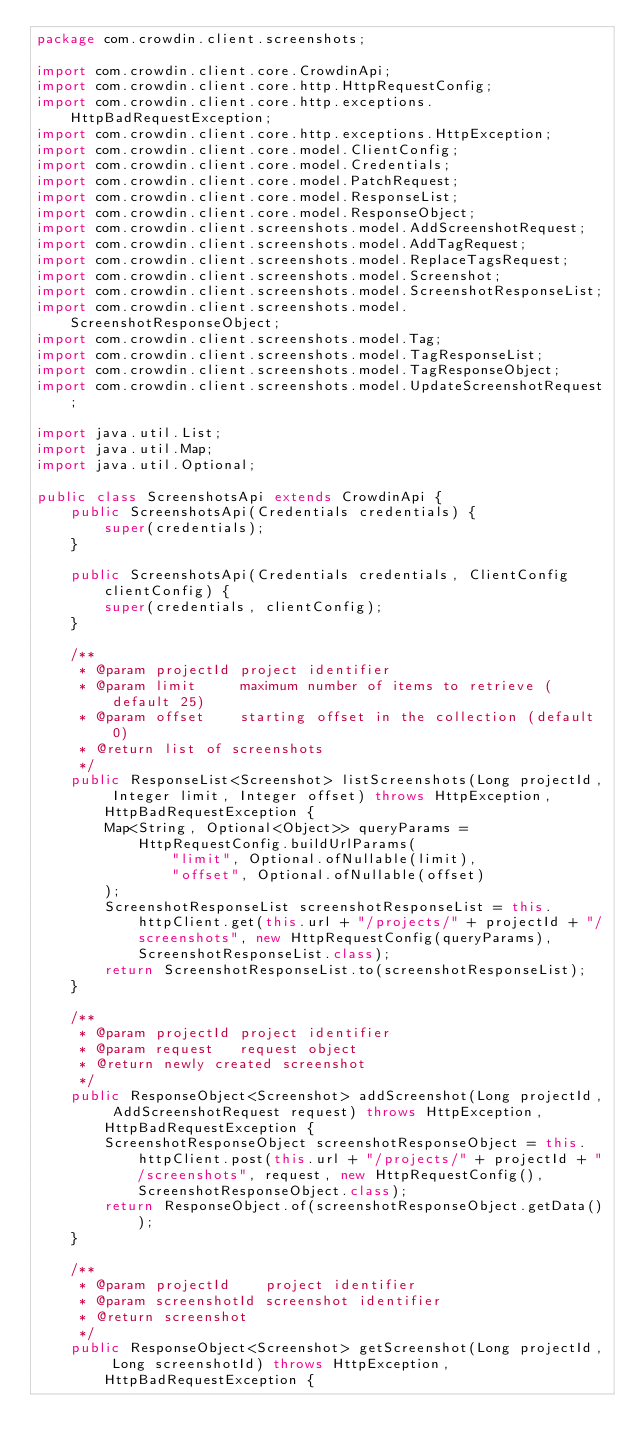Convert code to text. <code><loc_0><loc_0><loc_500><loc_500><_Java_>package com.crowdin.client.screenshots;

import com.crowdin.client.core.CrowdinApi;
import com.crowdin.client.core.http.HttpRequestConfig;
import com.crowdin.client.core.http.exceptions.HttpBadRequestException;
import com.crowdin.client.core.http.exceptions.HttpException;
import com.crowdin.client.core.model.ClientConfig;
import com.crowdin.client.core.model.Credentials;
import com.crowdin.client.core.model.PatchRequest;
import com.crowdin.client.core.model.ResponseList;
import com.crowdin.client.core.model.ResponseObject;
import com.crowdin.client.screenshots.model.AddScreenshotRequest;
import com.crowdin.client.screenshots.model.AddTagRequest;
import com.crowdin.client.screenshots.model.ReplaceTagsRequest;
import com.crowdin.client.screenshots.model.Screenshot;
import com.crowdin.client.screenshots.model.ScreenshotResponseList;
import com.crowdin.client.screenshots.model.ScreenshotResponseObject;
import com.crowdin.client.screenshots.model.Tag;
import com.crowdin.client.screenshots.model.TagResponseList;
import com.crowdin.client.screenshots.model.TagResponseObject;
import com.crowdin.client.screenshots.model.UpdateScreenshotRequest;

import java.util.List;
import java.util.Map;
import java.util.Optional;

public class ScreenshotsApi extends CrowdinApi {
    public ScreenshotsApi(Credentials credentials) {
        super(credentials);
    }

    public ScreenshotsApi(Credentials credentials, ClientConfig clientConfig) {
        super(credentials, clientConfig);
    }

    /**
     * @param projectId project identifier
     * @param limit     maximum number of items to retrieve (default 25)
     * @param offset    starting offset in the collection (default 0)
     * @return list of screenshots
     */
    public ResponseList<Screenshot> listScreenshots(Long projectId, Integer limit, Integer offset) throws HttpException, HttpBadRequestException {
        Map<String, Optional<Object>> queryParams = HttpRequestConfig.buildUrlParams(
                "limit", Optional.ofNullable(limit),
                "offset", Optional.ofNullable(offset)
        );
        ScreenshotResponseList screenshotResponseList = this.httpClient.get(this.url + "/projects/" + projectId + "/screenshots", new HttpRequestConfig(queryParams), ScreenshotResponseList.class);
        return ScreenshotResponseList.to(screenshotResponseList);
    }

    /**
     * @param projectId project identifier
     * @param request   request object
     * @return newly created screenshot
     */
    public ResponseObject<Screenshot> addScreenshot(Long projectId, AddScreenshotRequest request) throws HttpException, HttpBadRequestException {
        ScreenshotResponseObject screenshotResponseObject = this.httpClient.post(this.url + "/projects/" + projectId + "/screenshots", request, new HttpRequestConfig(), ScreenshotResponseObject.class);
        return ResponseObject.of(screenshotResponseObject.getData());
    }

    /**
     * @param projectId    project identifier
     * @param screenshotId screenshot identifier
     * @return screenshot
     */
    public ResponseObject<Screenshot> getScreenshot(Long projectId, Long screenshotId) throws HttpException, HttpBadRequestException {</code> 